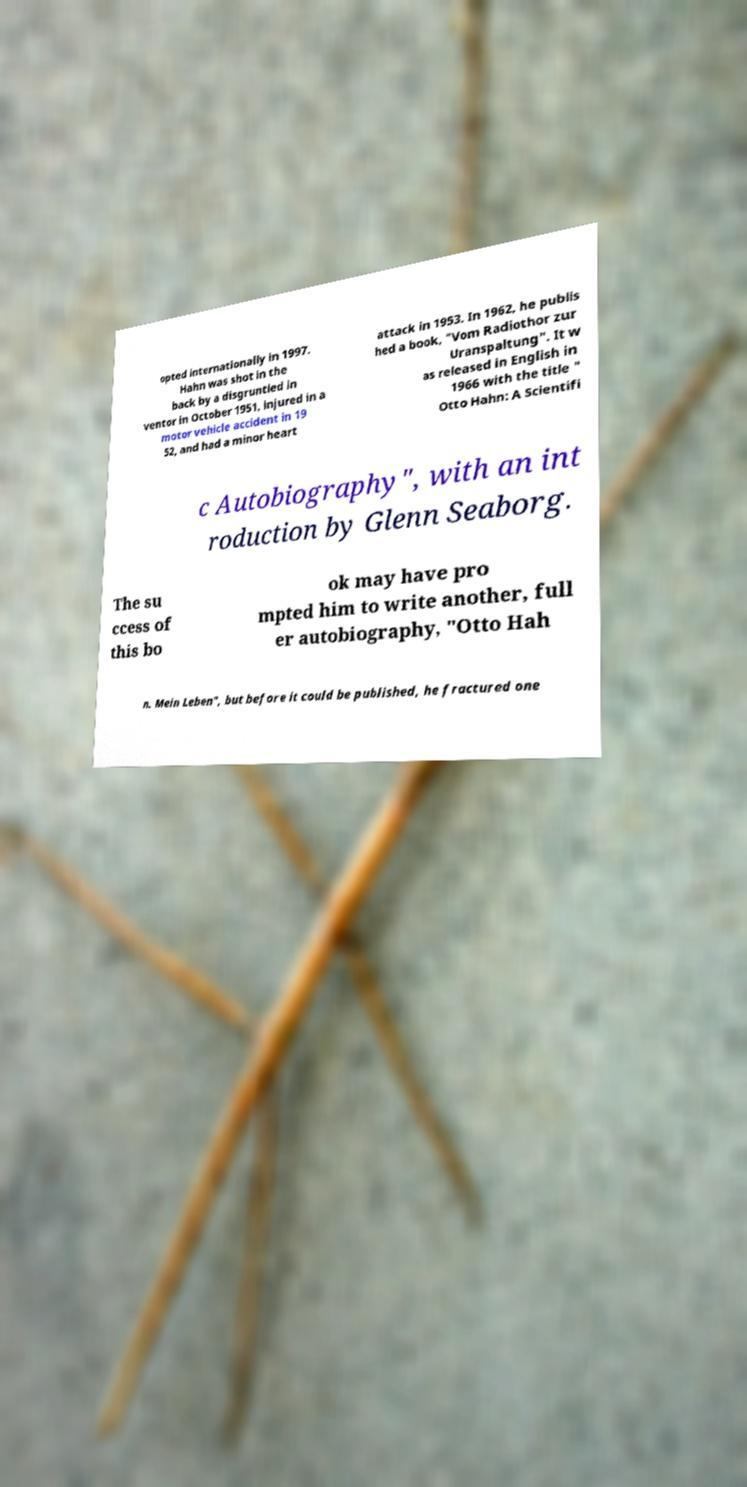There's text embedded in this image that I need extracted. Can you transcribe it verbatim? opted internationally in 1997. Hahn was shot in the back by a disgruntled in ventor in October 1951, injured in a motor vehicle accident in 19 52, and had a minor heart attack in 1953. In 1962, he publis hed a book, "Vom Radiothor zur Uranspaltung". It w as released in English in 1966 with the title " Otto Hahn: A Scientifi c Autobiography", with an int roduction by Glenn Seaborg. The su ccess of this bo ok may have pro mpted him to write another, full er autobiography, "Otto Hah n. Mein Leben", but before it could be published, he fractured one 